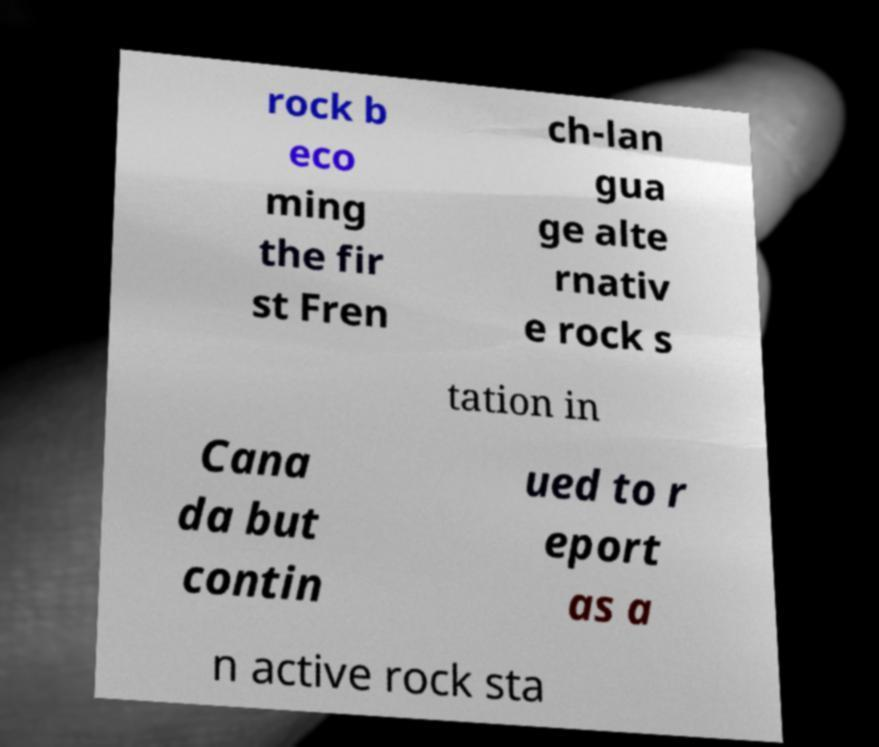Can you accurately transcribe the text from the provided image for me? rock b eco ming the fir st Fren ch-lan gua ge alte rnativ e rock s tation in Cana da but contin ued to r eport as a n active rock sta 